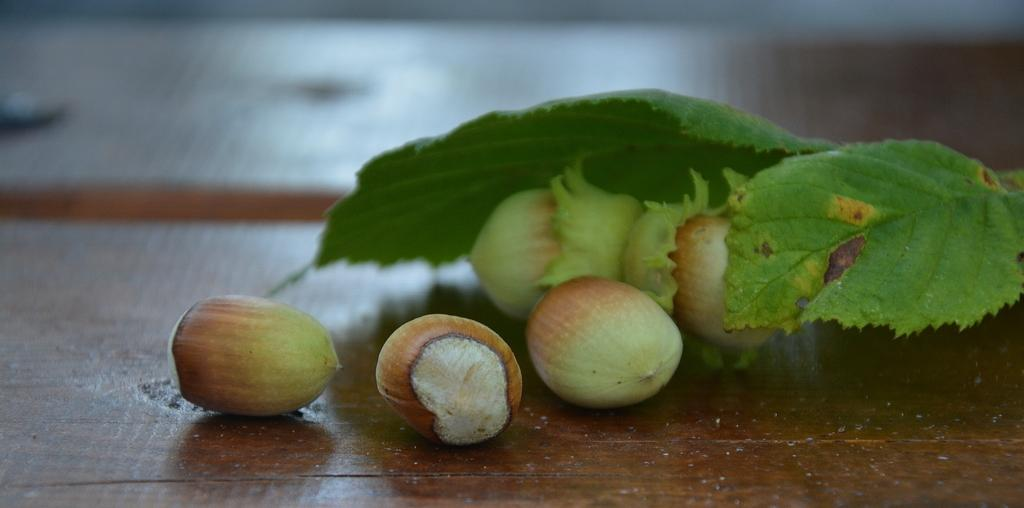What type of nuts can be seen on the wooden surface in the image? There are hazelnuts on a wooden surface in the image. What color are the leaves in the image? Green leaves are present in the image. Can you describe the background of the image? The background of the image is blurred. What type of jeans is the faucet wearing in the image? There is no faucet or jeans present in the image. 